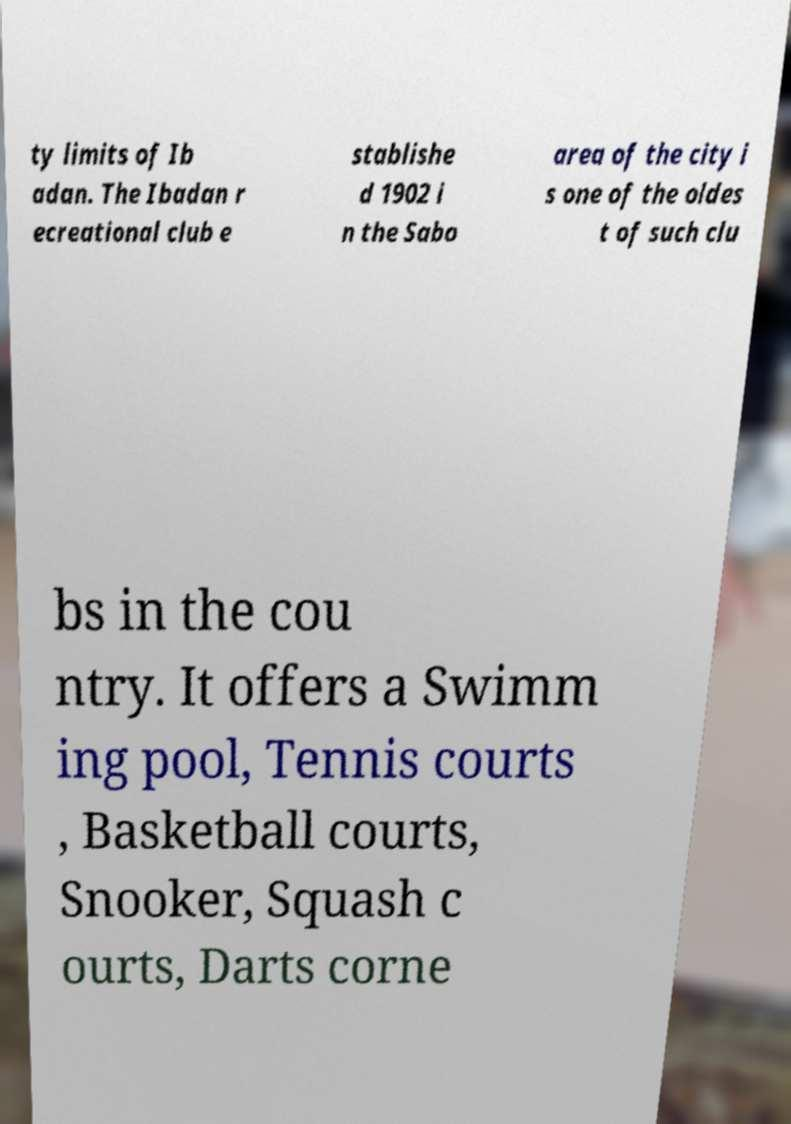Could you assist in decoding the text presented in this image and type it out clearly? ty limits of Ib adan. The Ibadan r ecreational club e stablishe d 1902 i n the Sabo area of the city i s one of the oldes t of such clu bs in the cou ntry. It offers a Swimm ing pool, Tennis courts , Basketball courts, Snooker, Squash c ourts, Darts corne 